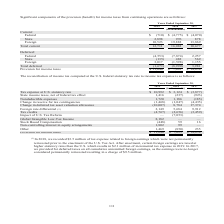According to Cubic's financial document, What does the table show? reconciliation of income tax computed at the U.S. federal statutory tax rate to income tax expense. The document states: "The reconciliation of income tax computed at the U.S. federal statutory tax rate to income tax expense is as follows:..." Also, What is the Tax expense at U.S. statutory rate for 2019? According to the financial document, $ 10,992 (in thousands). The relevant text states: "Tax expense at U.S. statutory rate $ 10,992 $ 3,124 $ (3,877) State income taxes, net of federal tax effect 1,416 (237) (923)..." Also, For which years was the reconciliation of income tax computed at the U.S. federal statutory tax rate to income tax expense provided? The document contains multiple relevant values: 2019, 2018, 2017. From the document: "Years Ended September 30, 2019 2018 2017 Years Ended September 30, 2019 2018 2017 Years Ended September 30, 2019 2018 2017..." Additionally, In which year was the provision for income taxes the largest? According to the financial document, 2017. The relevant text states: "Years Ended September 30, 2019 2018 2017..." Also, can you calculate: What is the change in nondeductible expenses in 2019 from 2018? Based on the calculation: 1,720-1,186, the result is 534 (in thousands). This is based on the information: "Nondeductible expenses 1,720 1,186 (185) Change in reserve for tax contingencies (1,468) (1,047) (4,435) Nondeductible expenses 1,720 1,186 (185) Change in reserve for tax contingencies (1,468) (1,047..." The key data points involved are: 1,186, 1,720. Also, can you calculate: What is the percentage change in nondeductible expenses in 2019 from 2018? To answer this question, I need to perform calculations using the financial data. The calculation is: (1,720-1,186)/1,186, which equals 45.03 (percentage). This is based on the information: "Nondeductible expenses 1,720 1,186 (185) Change in reserve for tax contingencies (1,468) (1,047) (4,435) Nondeductible expenses 1,720 1,186 (185) Change in reserve for tax contingencies (1,468) (1,047..." The key data points involved are: 1,186, 1,720. 